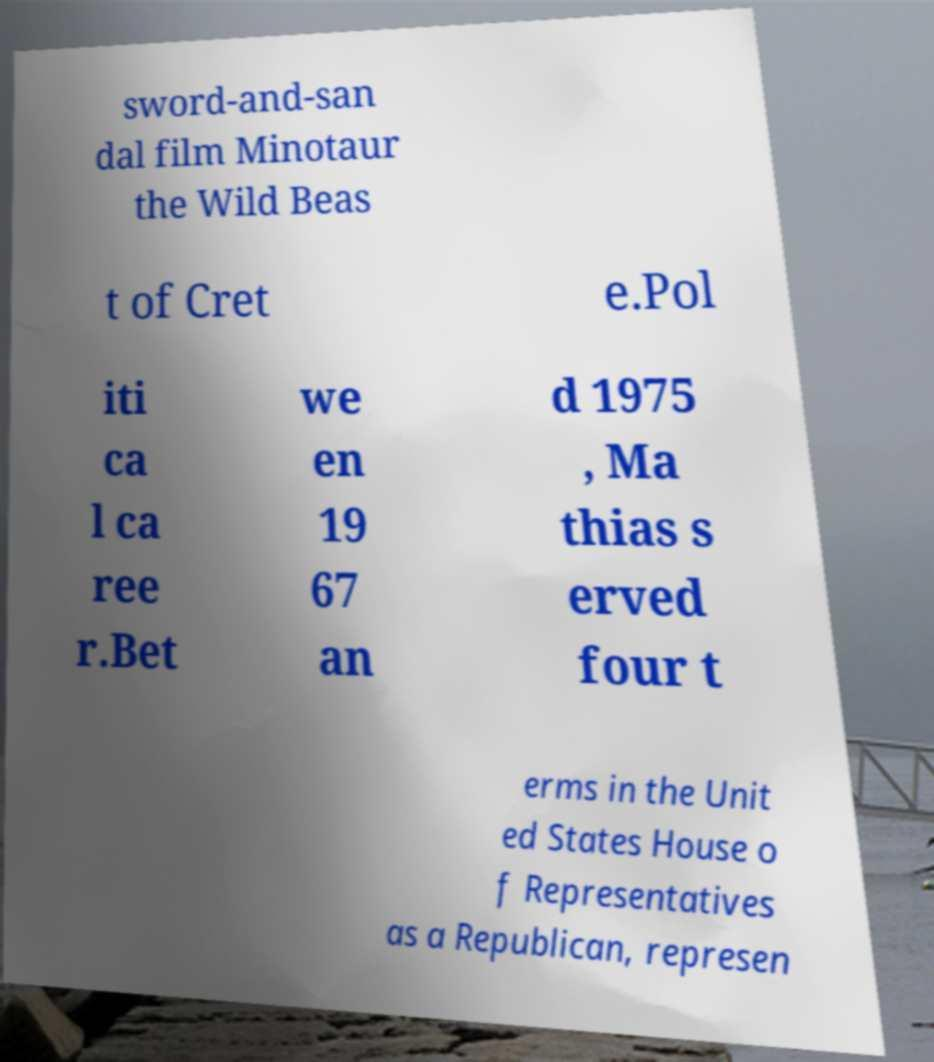I need the written content from this picture converted into text. Can you do that? sword-and-san dal film Minotaur the Wild Beas t of Cret e.Pol iti ca l ca ree r.Bet we en 19 67 an d 1975 , Ma thias s erved four t erms in the Unit ed States House o f Representatives as a Republican, represen 